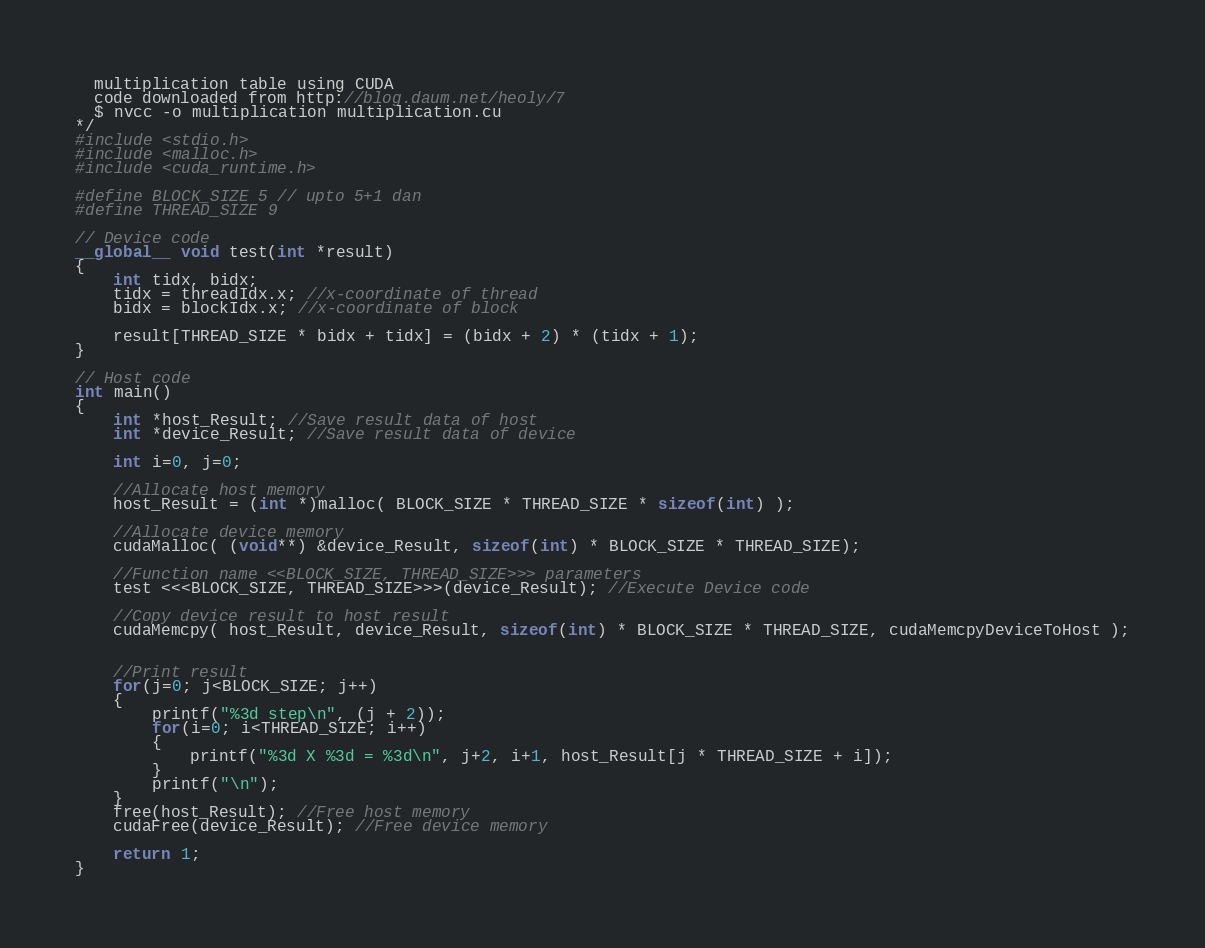Convert code to text. <code><loc_0><loc_0><loc_500><loc_500><_Cuda_>  multiplication table using CUDA
  code downloaded from http://blog.daum.net/heoly/7
  $ nvcc -o multiplication multiplication.cu
*/
#include <stdio.h>
#include <malloc.h>
#include <cuda_runtime.h>

#define BLOCK_SIZE 5 // upto 5+1 dan
#define THREAD_SIZE 9

// Device code
__global__ void test(int *result)
{
    int tidx, bidx;
    tidx = threadIdx.x; //x-coordinate of thread
    bidx = blockIdx.x; //x-coordinate of block

    result[THREAD_SIZE * bidx + tidx] = (bidx + 2) * (tidx + 1);
}

// Host code
int main()
{
    int *host_Result; //Save result data of host
    int *device_Result; //Save result data of device

    int i=0, j=0;

    //Allocate host memory
    host_Result = (int *)malloc( BLOCK_SIZE * THREAD_SIZE * sizeof(int) );

    //Allocate device memory
    cudaMalloc( (void**) &device_Result, sizeof(int) * BLOCK_SIZE * THREAD_SIZE);

    //Function name <<BLOCK_SIZE, THREAD_SIZE>>> parameters
    test <<<BLOCK_SIZE, THREAD_SIZE>>>(device_Result); //Execute Device code

    //Copy device result to host result
    cudaMemcpy( host_Result, device_Result, sizeof(int) * BLOCK_SIZE * THREAD_SIZE, cudaMemcpyDeviceToHost );


    //Print result
    for(j=0; j<BLOCK_SIZE; j++)
    {
        printf("%3d step\n", (j + 2));
        for(i=0; i<THREAD_SIZE; i++)
        {
            printf("%3d X %3d = %3d\n", j+2, i+1, host_Result[j * THREAD_SIZE + i]);
        }
        printf("\n");
    }
    free(host_Result); //Free host memory
    cudaFree(device_Result); //Free device memory

    return 1;
}
</code> 